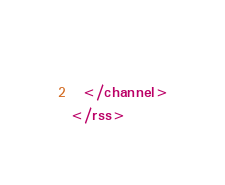Convert code to text. <code><loc_0><loc_0><loc_500><loc_500><_XML_>    
  </channel>
</rss></code> 